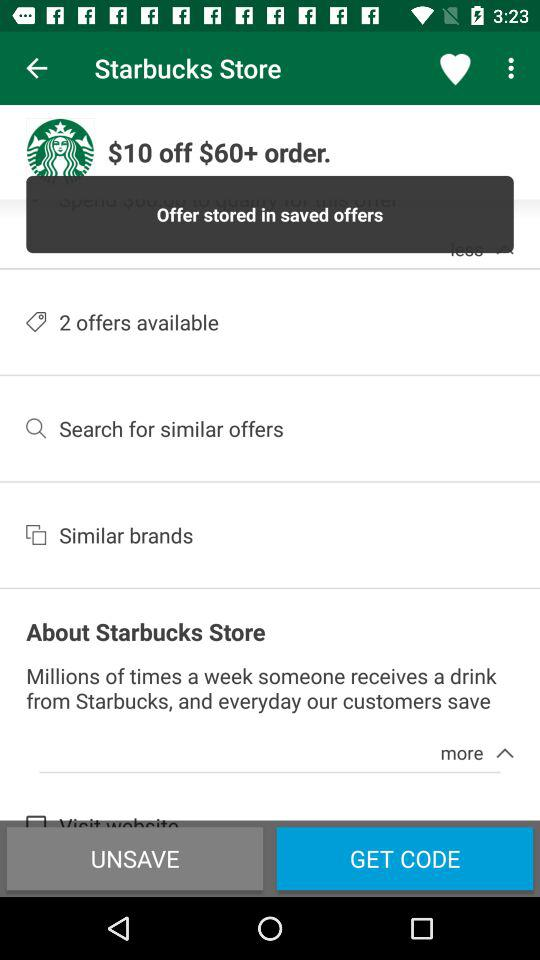Where is the offer stored? The offer is stored in saved offers. 